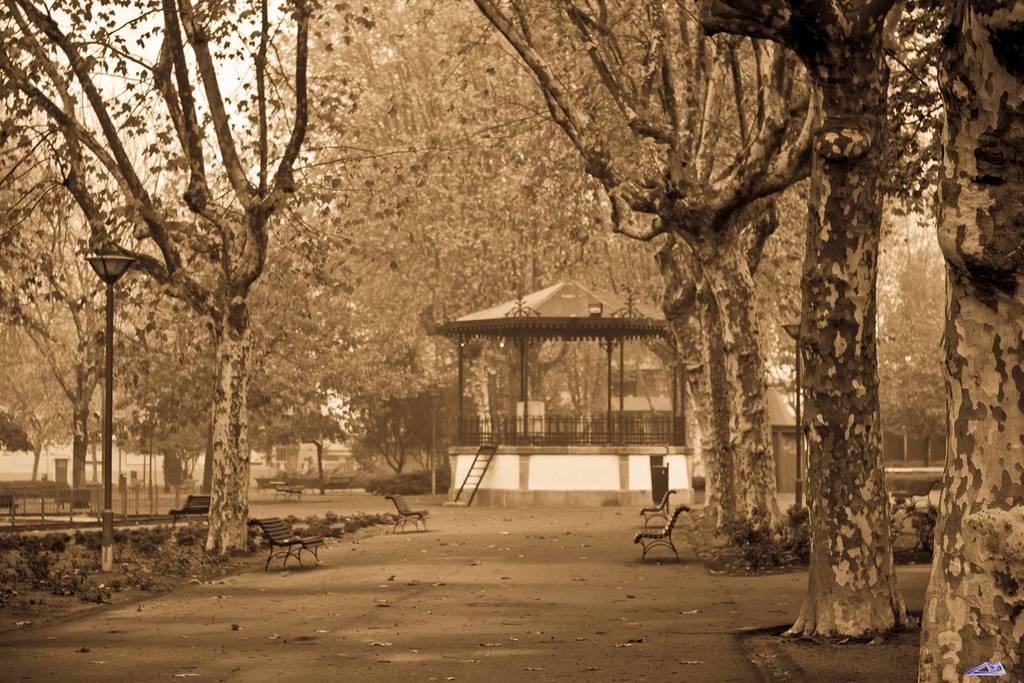What type of structures are present in the image? There are light poles, benches, and an open shed visible in the image. What type of vegetation can be seen in the image? There are plants and trees in the image. What is the purpose of the open shed in the image? The open shed appears to provide shelter or storage, as it has poles and railing inside. Can you describe the ladder visible in the distance? There is a ladder visible in the distance, but its specific purpose or location cannot be determined from the image. What religion is being practiced in the image? There is no indication of any religious practice or symbol in the image. How many elbows can be seen in the image? There are no elbows visible in the image, as it does not depict any people or body parts. 